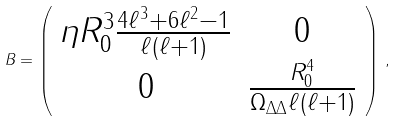Convert formula to latex. <formula><loc_0><loc_0><loc_500><loc_500>B = \left ( \begin{array} { c c } \eta R _ { 0 } ^ { 3 } \frac { 4 \ell ^ { 3 } + 6 \ell ^ { 2 } - 1 } { \ell ( \ell + 1 ) } & 0 \\ 0 & \frac { R _ { 0 } ^ { 4 } } { \Omega _ { \Delta \Delta } \ell ( \ell + 1 ) } \end{array} \right ) \, ,</formula> 